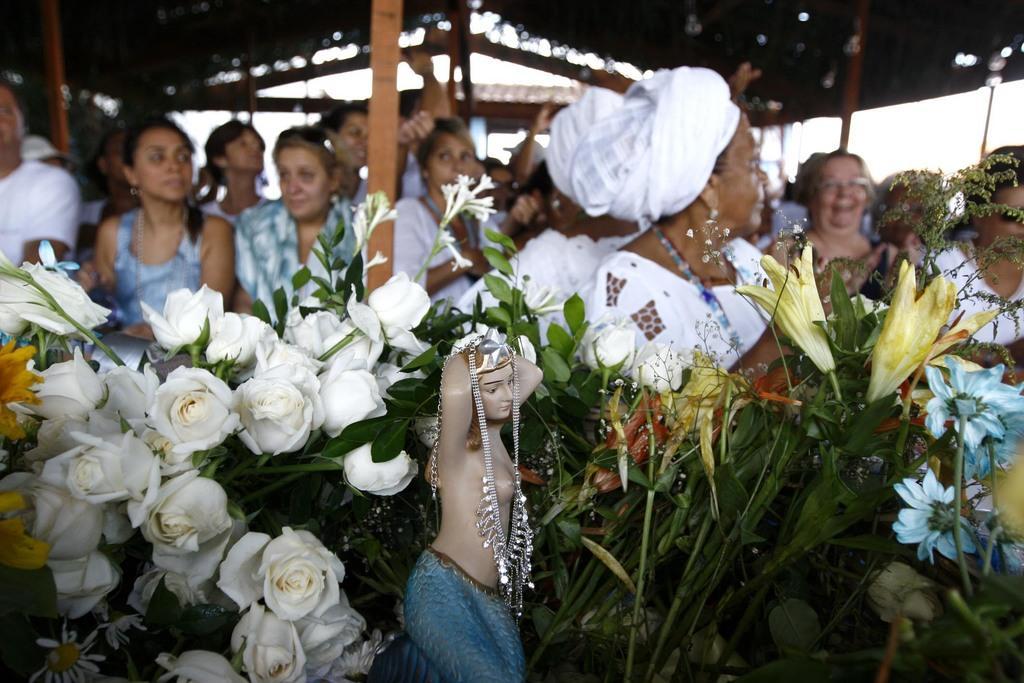Could you give a brief overview of what you see in this image? In this picture in the front there is a statue and there are flowers. In the background there are persons, there are poles and there are tents. 